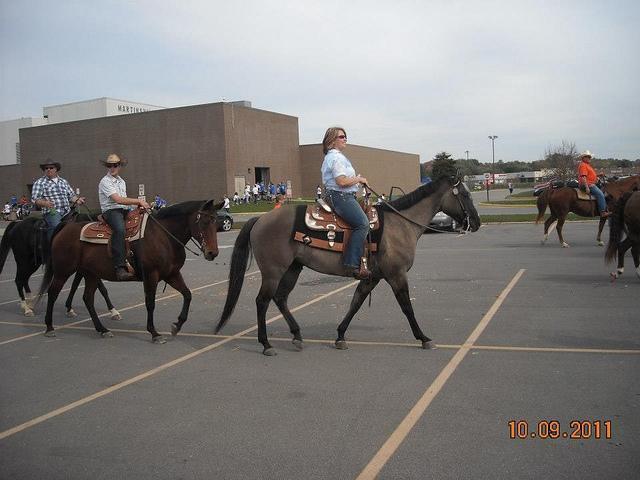How many horses are in the street?
Give a very brief answer. 5. How many awnings are visible?
Give a very brief answer. 0. How many animals are there?
Give a very brief answer. 5. How many hooves does the animal have on the ground right now in photo?
Give a very brief answer. 4. How many people can be seen?
Give a very brief answer. 3. How many horses can be seen?
Give a very brief answer. 4. 